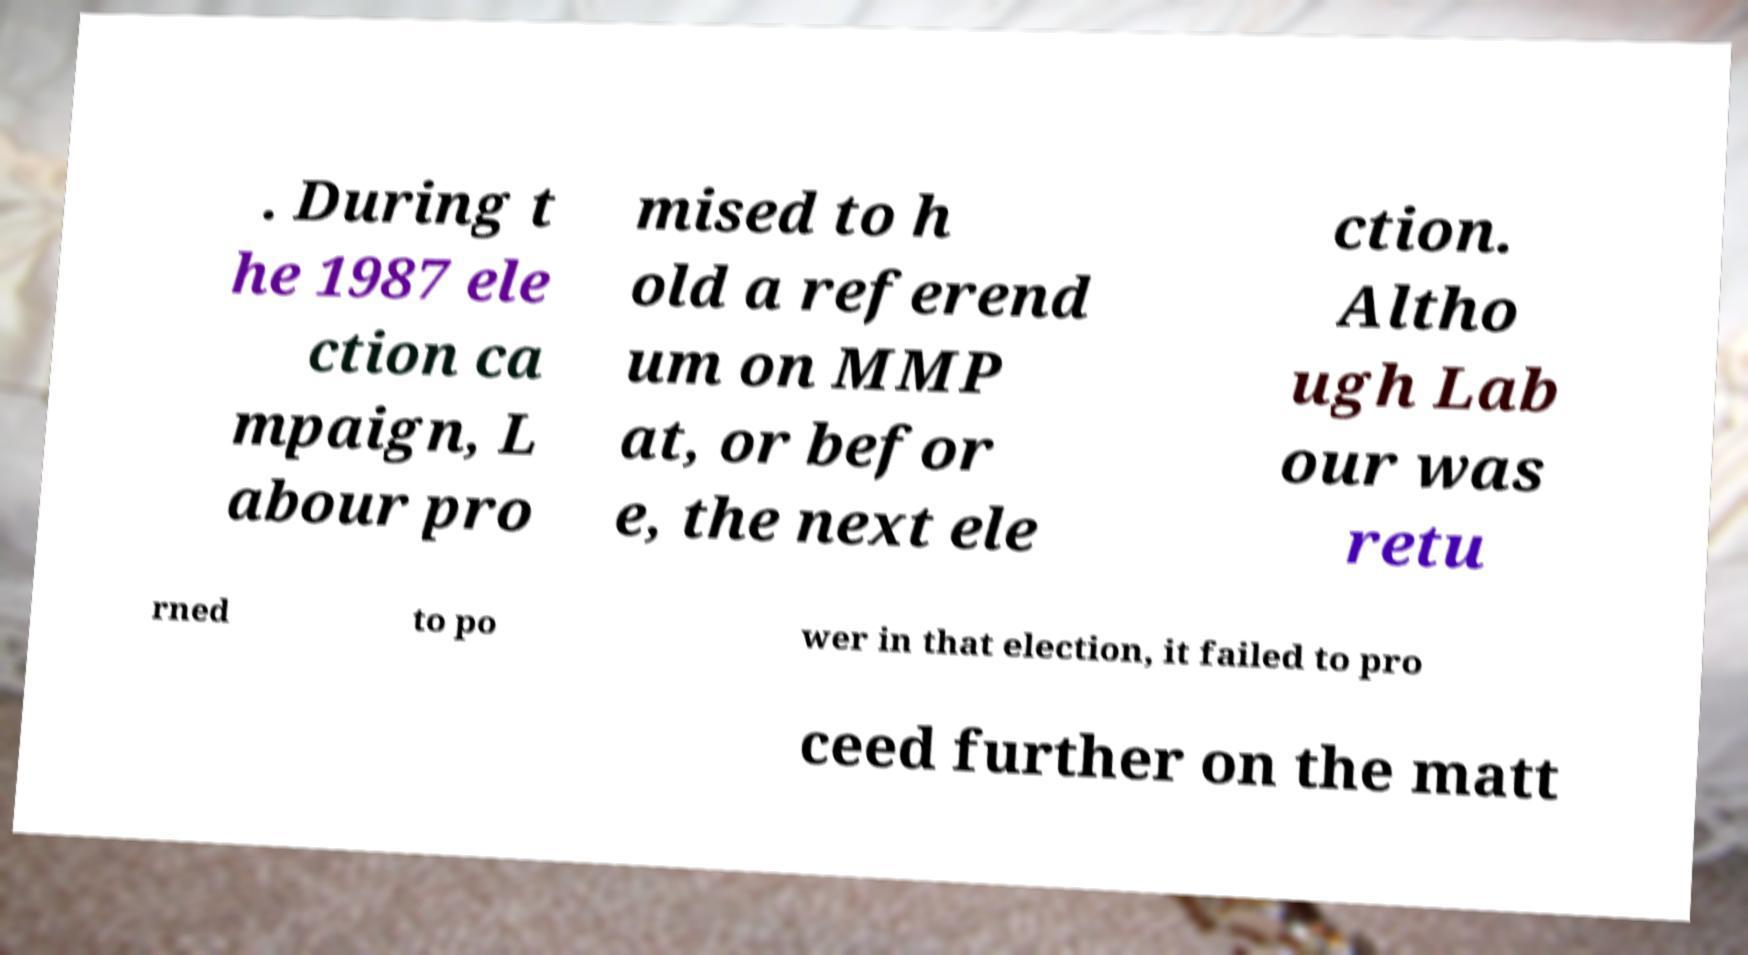Please identify and transcribe the text found in this image. . During t he 1987 ele ction ca mpaign, L abour pro mised to h old a referend um on MMP at, or befor e, the next ele ction. Altho ugh Lab our was retu rned to po wer in that election, it failed to pro ceed further on the matt 